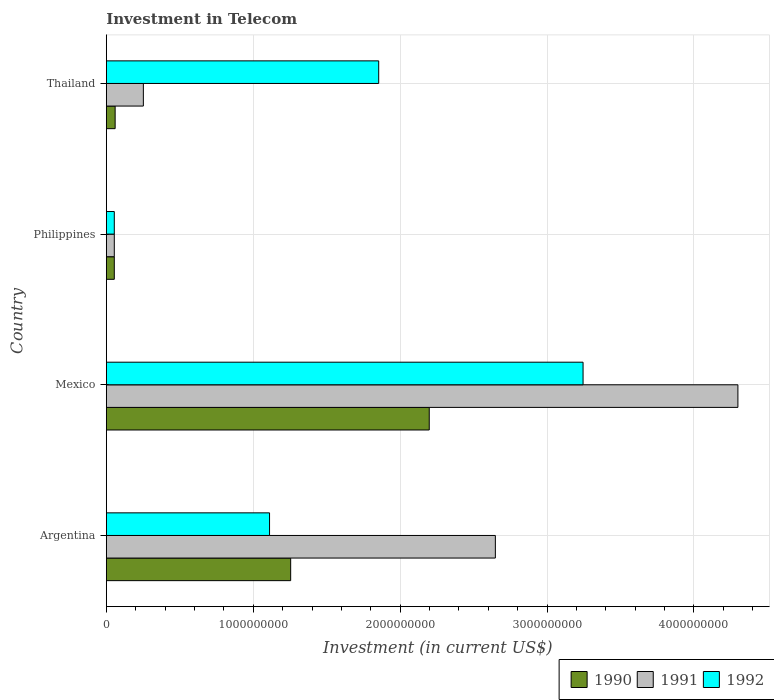How many different coloured bars are there?
Provide a short and direct response. 3. Are the number of bars per tick equal to the number of legend labels?
Provide a succinct answer. Yes. Are the number of bars on each tick of the Y-axis equal?
Keep it short and to the point. Yes. How many bars are there on the 2nd tick from the bottom?
Provide a succinct answer. 3. What is the label of the 2nd group of bars from the top?
Keep it short and to the point. Philippines. In how many cases, is the number of bars for a given country not equal to the number of legend labels?
Your response must be concise. 0. What is the amount invested in telecom in 1992 in Philippines?
Your answer should be very brief. 5.42e+07. Across all countries, what is the maximum amount invested in telecom in 1990?
Keep it short and to the point. 2.20e+09. Across all countries, what is the minimum amount invested in telecom in 1991?
Your answer should be compact. 5.42e+07. In which country was the amount invested in telecom in 1992 maximum?
Keep it short and to the point. Mexico. In which country was the amount invested in telecom in 1992 minimum?
Offer a very short reply. Philippines. What is the total amount invested in telecom in 1990 in the graph?
Ensure brevity in your answer.  3.57e+09. What is the difference between the amount invested in telecom in 1992 in Argentina and that in Philippines?
Make the answer very short. 1.06e+09. What is the difference between the amount invested in telecom in 1992 in Thailand and the amount invested in telecom in 1991 in Philippines?
Your answer should be compact. 1.80e+09. What is the average amount invested in telecom in 1992 per country?
Offer a very short reply. 1.57e+09. What is the difference between the amount invested in telecom in 1990 and amount invested in telecom in 1992 in Argentina?
Give a very brief answer. 1.44e+08. In how many countries, is the amount invested in telecom in 1990 greater than 4000000000 US$?
Provide a short and direct response. 0. What is the ratio of the amount invested in telecom in 1990 in Mexico to that in Thailand?
Make the answer very short. 36.63. Is the amount invested in telecom in 1990 in Argentina less than that in Mexico?
Keep it short and to the point. Yes. What is the difference between the highest and the second highest amount invested in telecom in 1992?
Your answer should be compact. 1.39e+09. What is the difference between the highest and the lowest amount invested in telecom in 1990?
Give a very brief answer. 2.14e+09. In how many countries, is the amount invested in telecom in 1990 greater than the average amount invested in telecom in 1990 taken over all countries?
Offer a terse response. 2. Is the sum of the amount invested in telecom in 1992 in Mexico and Thailand greater than the maximum amount invested in telecom in 1990 across all countries?
Offer a very short reply. Yes. What does the 3rd bar from the top in Philippines represents?
Provide a short and direct response. 1990. What does the 3rd bar from the bottom in Mexico represents?
Offer a very short reply. 1992. How many bars are there?
Make the answer very short. 12. How many countries are there in the graph?
Ensure brevity in your answer.  4. What is the difference between two consecutive major ticks on the X-axis?
Your answer should be compact. 1.00e+09. Are the values on the major ticks of X-axis written in scientific E-notation?
Your response must be concise. No. Does the graph contain grids?
Offer a terse response. Yes. How many legend labels are there?
Provide a short and direct response. 3. What is the title of the graph?
Your answer should be compact. Investment in Telecom. What is the label or title of the X-axis?
Offer a terse response. Investment (in current US$). What is the label or title of the Y-axis?
Offer a terse response. Country. What is the Investment (in current US$) of 1990 in Argentina?
Provide a short and direct response. 1.25e+09. What is the Investment (in current US$) in 1991 in Argentina?
Keep it short and to the point. 2.65e+09. What is the Investment (in current US$) of 1992 in Argentina?
Provide a short and direct response. 1.11e+09. What is the Investment (in current US$) in 1990 in Mexico?
Keep it short and to the point. 2.20e+09. What is the Investment (in current US$) in 1991 in Mexico?
Ensure brevity in your answer.  4.30e+09. What is the Investment (in current US$) of 1992 in Mexico?
Provide a short and direct response. 3.24e+09. What is the Investment (in current US$) in 1990 in Philippines?
Provide a succinct answer. 5.42e+07. What is the Investment (in current US$) in 1991 in Philippines?
Provide a short and direct response. 5.42e+07. What is the Investment (in current US$) in 1992 in Philippines?
Ensure brevity in your answer.  5.42e+07. What is the Investment (in current US$) of 1990 in Thailand?
Provide a short and direct response. 6.00e+07. What is the Investment (in current US$) of 1991 in Thailand?
Offer a very short reply. 2.52e+08. What is the Investment (in current US$) in 1992 in Thailand?
Ensure brevity in your answer.  1.85e+09. Across all countries, what is the maximum Investment (in current US$) of 1990?
Keep it short and to the point. 2.20e+09. Across all countries, what is the maximum Investment (in current US$) in 1991?
Your response must be concise. 4.30e+09. Across all countries, what is the maximum Investment (in current US$) of 1992?
Your answer should be compact. 3.24e+09. Across all countries, what is the minimum Investment (in current US$) of 1990?
Your answer should be very brief. 5.42e+07. Across all countries, what is the minimum Investment (in current US$) in 1991?
Provide a succinct answer. 5.42e+07. Across all countries, what is the minimum Investment (in current US$) of 1992?
Offer a terse response. 5.42e+07. What is the total Investment (in current US$) of 1990 in the graph?
Keep it short and to the point. 3.57e+09. What is the total Investment (in current US$) in 1991 in the graph?
Your response must be concise. 7.25e+09. What is the total Investment (in current US$) of 1992 in the graph?
Offer a terse response. 6.26e+09. What is the difference between the Investment (in current US$) of 1990 in Argentina and that in Mexico?
Your answer should be very brief. -9.43e+08. What is the difference between the Investment (in current US$) of 1991 in Argentina and that in Mexico?
Make the answer very short. -1.65e+09. What is the difference between the Investment (in current US$) in 1992 in Argentina and that in Mexico?
Give a very brief answer. -2.13e+09. What is the difference between the Investment (in current US$) of 1990 in Argentina and that in Philippines?
Your answer should be compact. 1.20e+09. What is the difference between the Investment (in current US$) in 1991 in Argentina and that in Philippines?
Keep it short and to the point. 2.59e+09. What is the difference between the Investment (in current US$) of 1992 in Argentina and that in Philippines?
Give a very brief answer. 1.06e+09. What is the difference between the Investment (in current US$) of 1990 in Argentina and that in Thailand?
Ensure brevity in your answer.  1.19e+09. What is the difference between the Investment (in current US$) of 1991 in Argentina and that in Thailand?
Give a very brief answer. 2.40e+09. What is the difference between the Investment (in current US$) of 1992 in Argentina and that in Thailand?
Ensure brevity in your answer.  -7.43e+08. What is the difference between the Investment (in current US$) of 1990 in Mexico and that in Philippines?
Your answer should be compact. 2.14e+09. What is the difference between the Investment (in current US$) in 1991 in Mexico and that in Philippines?
Your answer should be very brief. 4.24e+09. What is the difference between the Investment (in current US$) in 1992 in Mexico and that in Philippines?
Your answer should be compact. 3.19e+09. What is the difference between the Investment (in current US$) in 1990 in Mexico and that in Thailand?
Offer a very short reply. 2.14e+09. What is the difference between the Investment (in current US$) of 1991 in Mexico and that in Thailand?
Offer a very short reply. 4.05e+09. What is the difference between the Investment (in current US$) of 1992 in Mexico and that in Thailand?
Offer a terse response. 1.39e+09. What is the difference between the Investment (in current US$) of 1990 in Philippines and that in Thailand?
Provide a succinct answer. -5.80e+06. What is the difference between the Investment (in current US$) in 1991 in Philippines and that in Thailand?
Your response must be concise. -1.98e+08. What is the difference between the Investment (in current US$) of 1992 in Philippines and that in Thailand?
Your answer should be compact. -1.80e+09. What is the difference between the Investment (in current US$) in 1990 in Argentina and the Investment (in current US$) in 1991 in Mexico?
Provide a succinct answer. -3.04e+09. What is the difference between the Investment (in current US$) in 1990 in Argentina and the Investment (in current US$) in 1992 in Mexico?
Keep it short and to the point. -1.99e+09. What is the difference between the Investment (in current US$) of 1991 in Argentina and the Investment (in current US$) of 1992 in Mexico?
Your response must be concise. -5.97e+08. What is the difference between the Investment (in current US$) of 1990 in Argentina and the Investment (in current US$) of 1991 in Philippines?
Your answer should be very brief. 1.20e+09. What is the difference between the Investment (in current US$) in 1990 in Argentina and the Investment (in current US$) in 1992 in Philippines?
Keep it short and to the point. 1.20e+09. What is the difference between the Investment (in current US$) of 1991 in Argentina and the Investment (in current US$) of 1992 in Philippines?
Offer a very short reply. 2.59e+09. What is the difference between the Investment (in current US$) of 1990 in Argentina and the Investment (in current US$) of 1991 in Thailand?
Ensure brevity in your answer.  1.00e+09. What is the difference between the Investment (in current US$) of 1990 in Argentina and the Investment (in current US$) of 1992 in Thailand?
Offer a terse response. -5.99e+08. What is the difference between the Investment (in current US$) in 1991 in Argentina and the Investment (in current US$) in 1992 in Thailand?
Your answer should be compact. 7.94e+08. What is the difference between the Investment (in current US$) of 1990 in Mexico and the Investment (in current US$) of 1991 in Philippines?
Make the answer very short. 2.14e+09. What is the difference between the Investment (in current US$) in 1990 in Mexico and the Investment (in current US$) in 1992 in Philippines?
Your response must be concise. 2.14e+09. What is the difference between the Investment (in current US$) of 1991 in Mexico and the Investment (in current US$) of 1992 in Philippines?
Give a very brief answer. 4.24e+09. What is the difference between the Investment (in current US$) of 1990 in Mexico and the Investment (in current US$) of 1991 in Thailand?
Your answer should be very brief. 1.95e+09. What is the difference between the Investment (in current US$) of 1990 in Mexico and the Investment (in current US$) of 1992 in Thailand?
Provide a short and direct response. 3.44e+08. What is the difference between the Investment (in current US$) in 1991 in Mexico and the Investment (in current US$) in 1992 in Thailand?
Give a very brief answer. 2.44e+09. What is the difference between the Investment (in current US$) in 1990 in Philippines and the Investment (in current US$) in 1991 in Thailand?
Make the answer very short. -1.98e+08. What is the difference between the Investment (in current US$) of 1990 in Philippines and the Investment (in current US$) of 1992 in Thailand?
Your answer should be very brief. -1.80e+09. What is the difference between the Investment (in current US$) in 1991 in Philippines and the Investment (in current US$) in 1992 in Thailand?
Offer a terse response. -1.80e+09. What is the average Investment (in current US$) in 1990 per country?
Offer a very short reply. 8.92e+08. What is the average Investment (in current US$) in 1991 per country?
Give a very brief answer. 1.81e+09. What is the average Investment (in current US$) in 1992 per country?
Give a very brief answer. 1.57e+09. What is the difference between the Investment (in current US$) in 1990 and Investment (in current US$) in 1991 in Argentina?
Make the answer very short. -1.39e+09. What is the difference between the Investment (in current US$) of 1990 and Investment (in current US$) of 1992 in Argentina?
Make the answer very short. 1.44e+08. What is the difference between the Investment (in current US$) of 1991 and Investment (in current US$) of 1992 in Argentina?
Give a very brief answer. 1.54e+09. What is the difference between the Investment (in current US$) of 1990 and Investment (in current US$) of 1991 in Mexico?
Provide a short and direct response. -2.10e+09. What is the difference between the Investment (in current US$) of 1990 and Investment (in current US$) of 1992 in Mexico?
Offer a very short reply. -1.05e+09. What is the difference between the Investment (in current US$) of 1991 and Investment (in current US$) of 1992 in Mexico?
Your response must be concise. 1.05e+09. What is the difference between the Investment (in current US$) in 1990 and Investment (in current US$) in 1991 in Philippines?
Your response must be concise. 0. What is the difference between the Investment (in current US$) of 1990 and Investment (in current US$) of 1992 in Philippines?
Provide a short and direct response. 0. What is the difference between the Investment (in current US$) in 1991 and Investment (in current US$) in 1992 in Philippines?
Give a very brief answer. 0. What is the difference between the Investment (in current US$) in 1990 and Investment (in current US$) in 1991 in Thailand?
Your answer should be very brief. -1.92e+08. What is the difference between the Investment (in current US$) in 1990 and Investment (in current US$) in 1992 in Thailand?
Keep it short and to the point. -1.79e+09. What is the difference between the Investment (in current US$) of 1991 and Investment (in current US$) of 1992 in Thailand?
Keep it short and to the point. -1.60e+09. What is the ratio of the Investment (in current US$) of 1990 in Argentina to that in Mexico?
Offer a very short reply. 0.57. What is the ratio of the Investment (in current US$) in 1991 in Argentina to that in Mexico?
Your answer should be compact. 0.62. What is the ratio of the Investment (in current US$) in 1992 in Argentina to that in Mexico?
Your answer should be compact. 0.34. What is the ratio of the Investment (in current US$) in 1990 in Argentina to that in Philippines?
Offer a terse response. 23.15. What is the ratio of the Investment (in current US$) in 1991 in Argentina to that in Philippines?
Your answer should be compact. 48.86. What is the ratio of the Investment (in current US$) of 1992 in Argentina to that in Philippines?
Offer a very short reply. 20.5. What is the ratio of the Investment (in current US$) in 1990 in Argentina to that in Thailand?
Your answer should be compact. 20.91. What is the ratio of the Investment (in current US$) of 1991 in Argentina to that in Thailand?
Provide a short and direct response. 10.51. What is the ratio of the Investment (in current US$) in 1992 in Argentina to that in Thailand?
Offer a terse response. 0.6. What is the ratio of the Investment (in current US$) of 1990 in Mexico to that in Philippines?
Ensure brevity in your answer.  40.55. What is the ratio of the Investment (in current US$) in 1991 in Mexico to that in Philippines?
Your response must be concise. 79.32. What is the ratio of the Investment (in current US$) of 1992 in Mexico to that in Philippines?
Your answer should be very brief. 59.87. What is the ratio of the Investment (in current US$) of 1990 in Mexico to that in Thailand?
Your answer should be very brief. 36.63. What is the ratio of the Investment (in current US$) of 1991 in Mexico to that in Thailand?
Keep it short and to the point. 17.06. What is the ratio of the Investment (in current US$) of 1992 in Mexico to that in Thailand?
Offer a very short reply. 1.75. What is the ratio of the Investment (in current US$) in 1990 in Philippines to that in Thailand?
Keep it short and to the point. 0.9. What is the ratio of the Investment (in current US$) in 1991 in Philippines to that in Thailand?
Keep it short and to the point. 0.22. What is the ratio of the Investment (in current US$) of 1992 in Philippines to that in Thailand?
Provide a short and direct response. 0.03. What is the difference between the highest and the second highest Investment (in current US$) of 1990?
Your response must be concise. 9.43e+08. What is the difference between the highest and the second highest Investment (in current US$) of 1991?
Your answer should be compact. 1.65e+09. What is the difference between the highest and the second highest Investment (in current US$) of 1992?
Your answer should be very brief. 1.39e+09. What is the difference between the highest and the lowest Investment (in current US$) in 1990?
Offer a terse response. 2.14e+09. What is the difference between the highest and the lowest Investment (in current US$) of 1991?
Ensure brevity in your answer.  4.24e+09. What is the difference between the highest and the lowest Investment (in current US$) of 1992?
Give a very brief answer. 3.19e+09. 